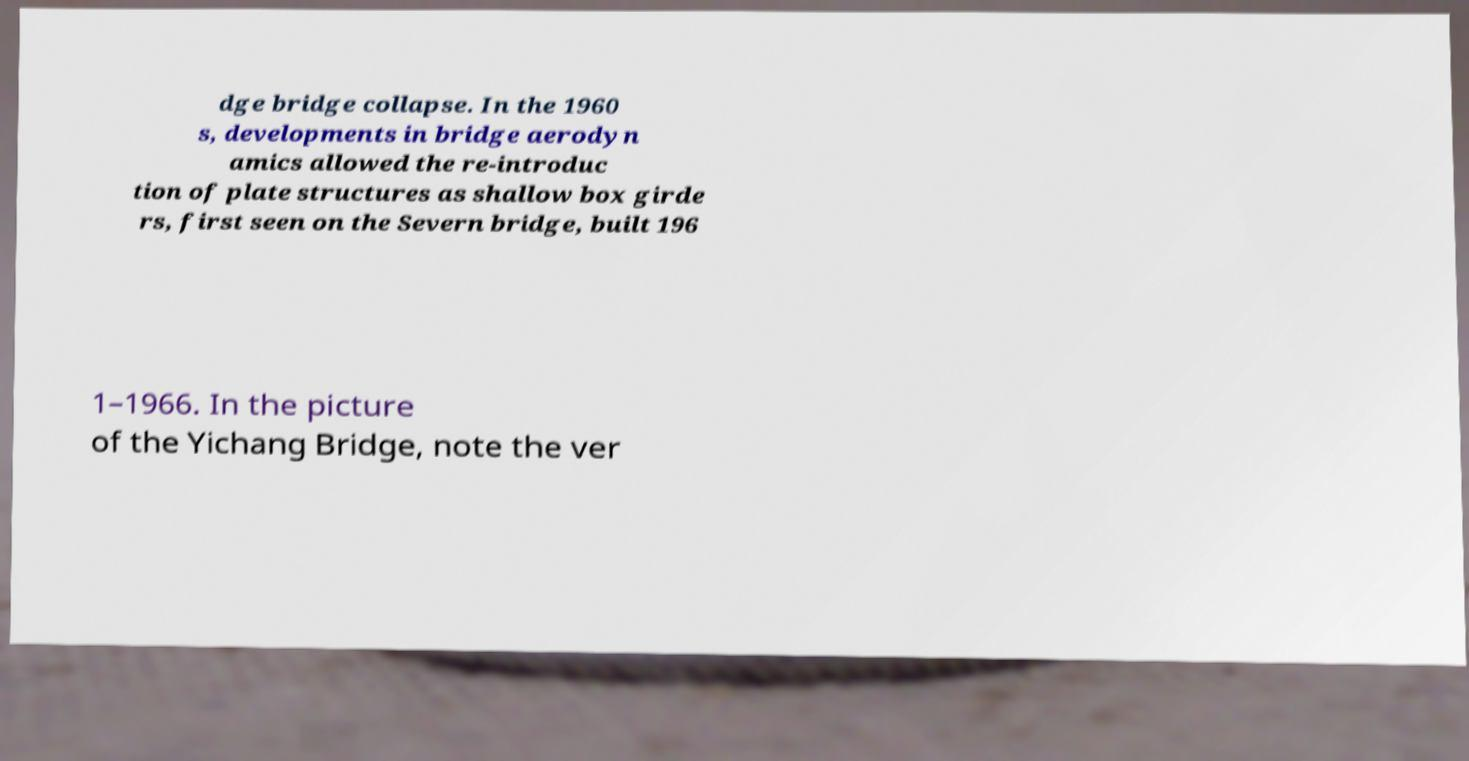What messages or text are displayed in this image? I need them in a readable, typed format. dge bridge collapse. In the 1960 s, developments in bridge aerodyn amics allowed the re-introduc tion of plate structures as shallow box girde rs, first seen on the Severn bridge, built 196 1–1966. In the picture of the Yichang Bridge, note the ver 